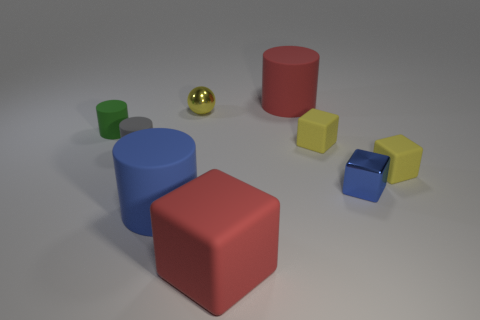What number of tiny gray rubber objects are right of the blue thing that is to the left of the red thing that is in front of the small shiny block?
Keep it short and to the point. 0. There is a green object; is its shape the same as the red object that is in front of the yellow metallic thing?
Offer a very short reply. No. There is a thing that is both to the right of the blue cylinder and to the left of the large block; what color is it?
Offer a terse response. Yellow. What is the yellow thing that is to the left of the cylinder on the right side of the large red object that is on the left side of the red cylinder made of?
Provide a succinct answer. Metal. What is the material of the small sphere?
Provide a short and direct response. Metal. There is a blue rubber object that is the same shape as the green matte thing; what is its size?
Offer a very short reply. Large. Does the sphere have the same color as the shiny block?
Offer a very short reply. No. What number of other things are made of the same material as the large red cube?
Your answer should be compact. 6. Are there an equal number of shiny spheres that are behind the blue metallic object and blue matte objects?
Offer a terse response. Yes. Do the cylinder that is behind the green cylinder and the small green rubber cylinder have the same size?
Your answer should be very brief. No. 